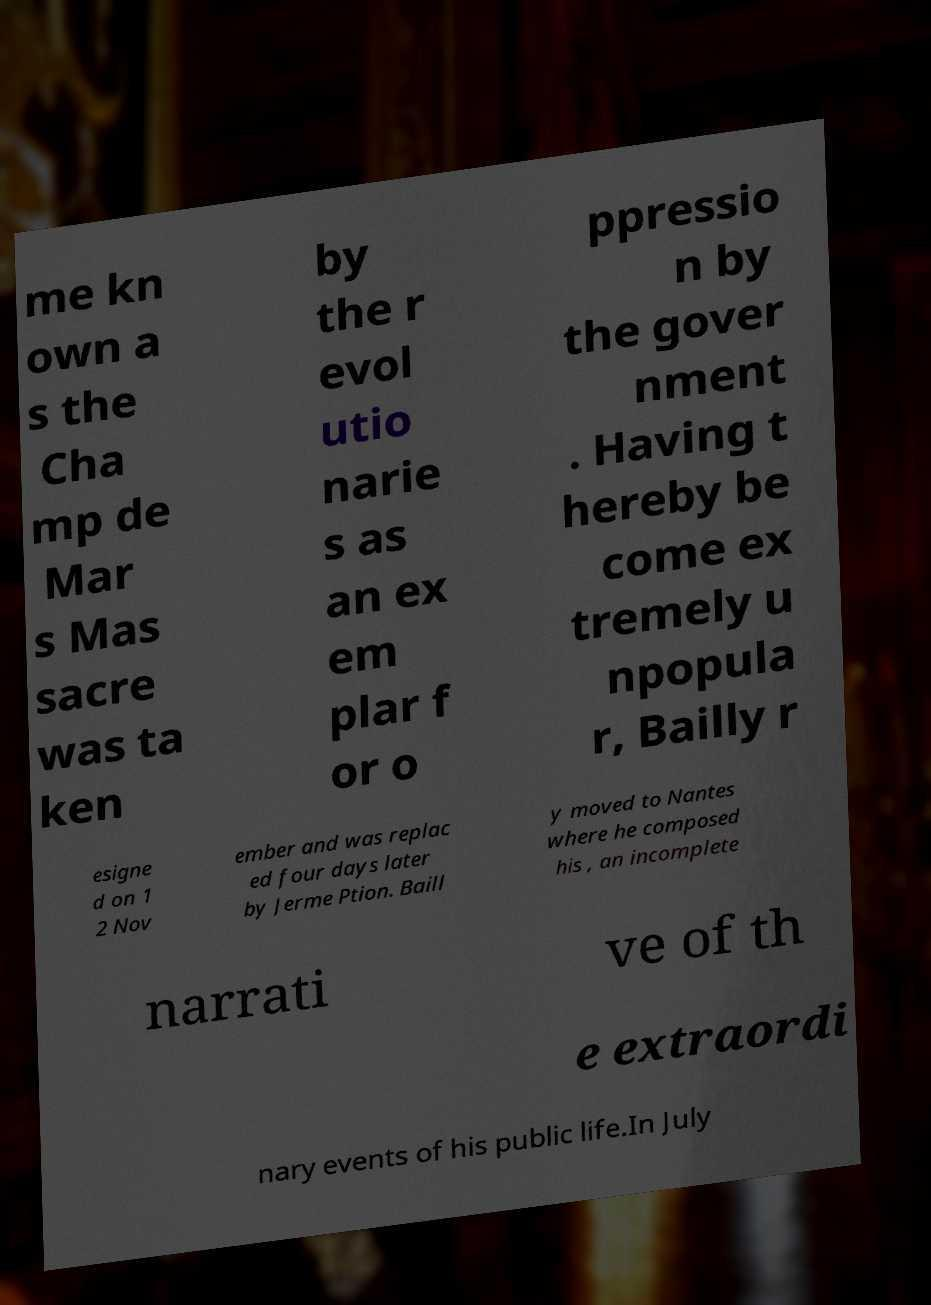I need the written content from this picture converted into text. Can you do that? me kn own a s the Cha mp de Mar s Mas sacre was ta ken by the r evol utio narie s as an ex em plar f or o ppressio n by the gover nment . Having t hereby be come ex tremely u npopula r, Bailly r esigne d on 1 2 Nov ember and was replac ed four days later by Jerme Ption. Baill y moved to Nantes where he composed his , an incomplete narrati ve of th e extraordi nary events of his public life.In July 